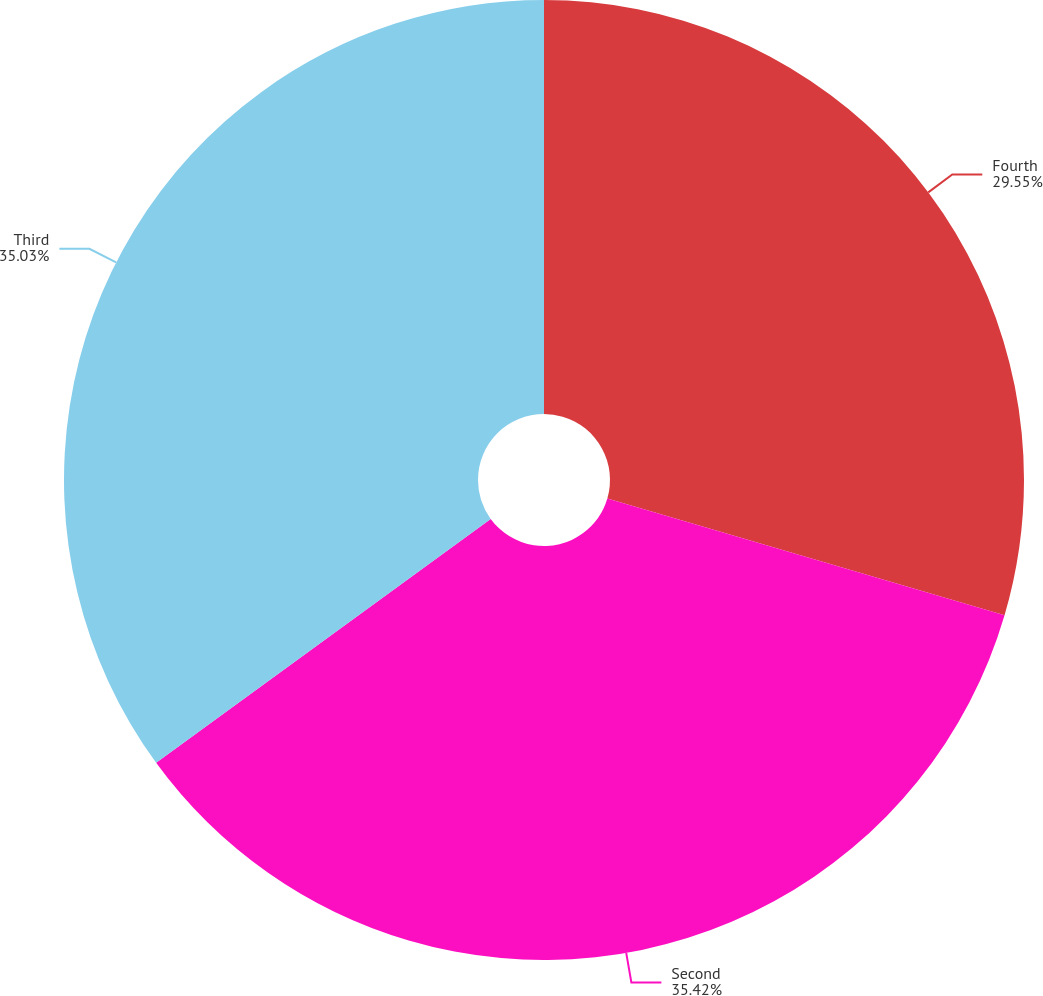<chart> <loc_0><loc_0><loc_500><loc_500><pie_chart><fcel>Fourth<fcel>Second<fcel>Third<nl><fcel>29.55%<fcel>35.43%<fcel>35.03%<nl></chart> 